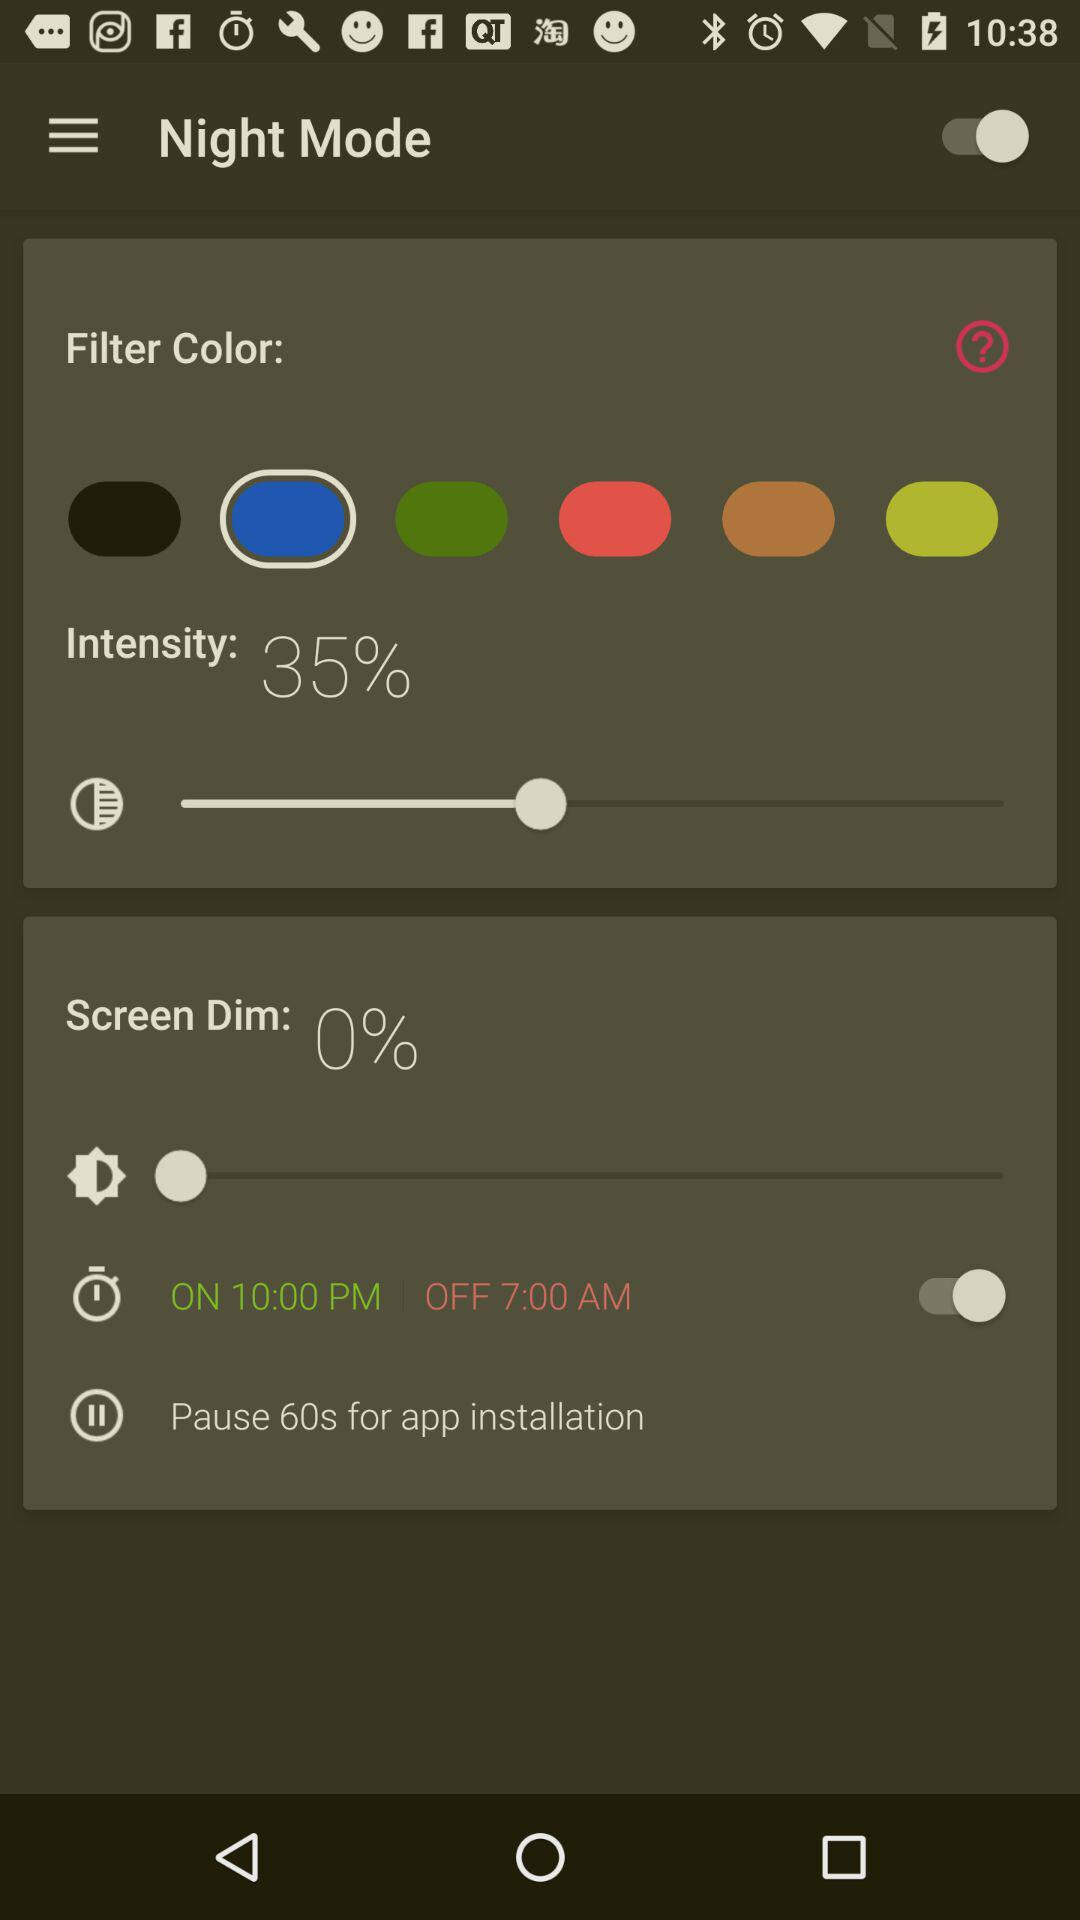What is the screen dim percentage? The screen dim percentage is 0. 